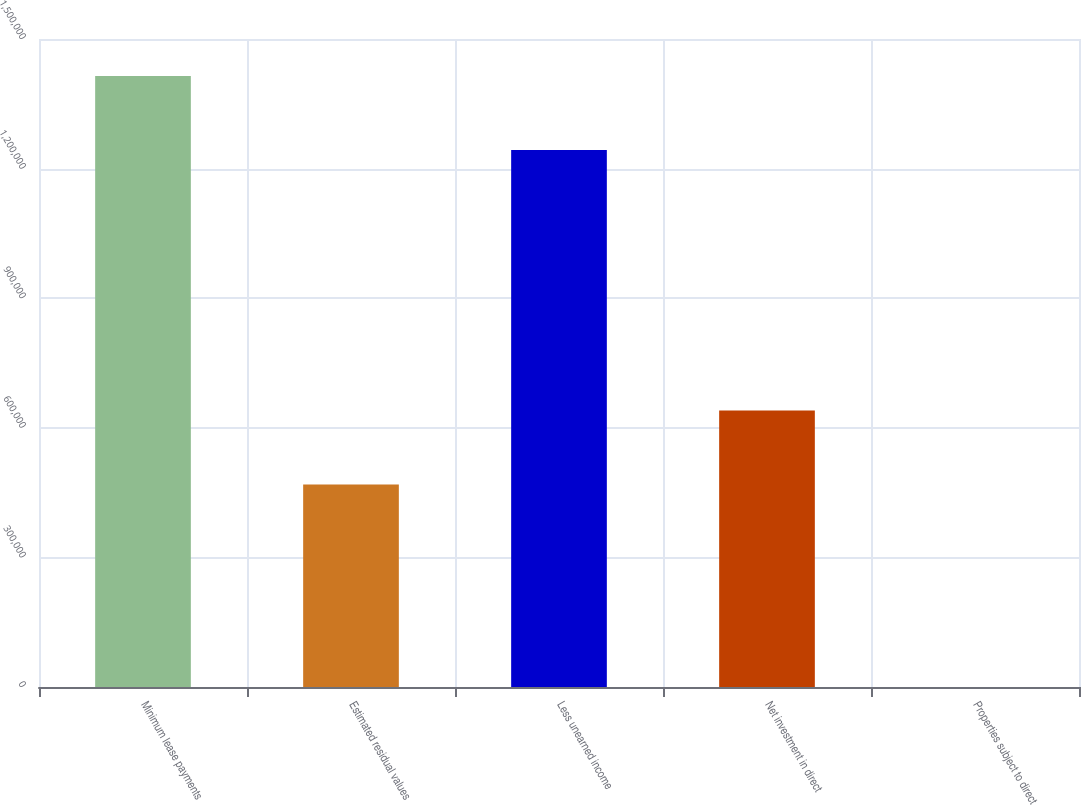<chart> <loc_0><loc_0><loc_500><loc_500><bar_chart><fcel>Minimum lease payments<fcel>Estimated residual values<fcel>Less unearned income<fcel>Net investment in direct<fcel>Properties subject to direct<nl><fcel>1.41412e+06<fcel>468769<fcel>1.24283e+06<fcel>640052<fcel>30<nl></chart> 